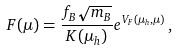Convert formula to latex. <formula><loc_0><loc_0><loc_500><loc_500>F ( \mu ) = \frac { f _ { B } \sqrt { m _ { B } } } { K ( \mu _ { h } ) } e ^ { V _ { F } ( \mu _ { h } , \mu ) } \, ,</formula> 